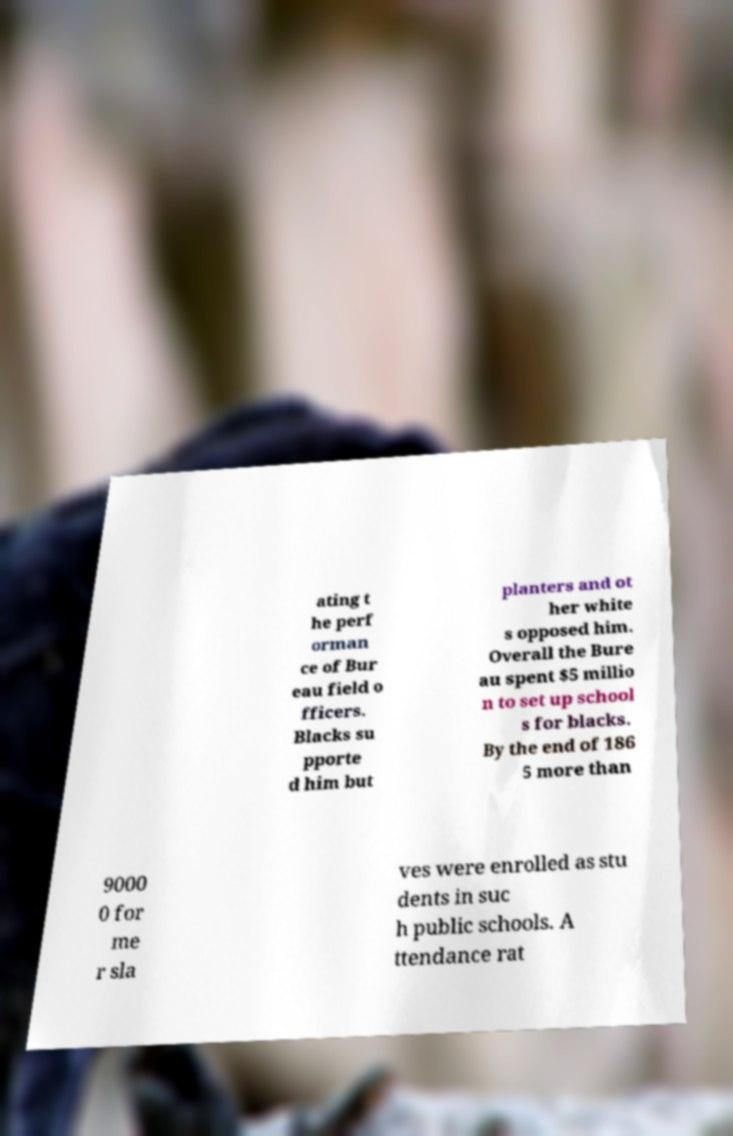Could you extract and type out the text from this image? ating t he perf orman ce of Bur eau field o fficers. Blacks su pporte d him but planters and ot her white s opposed him. Overall the Bure au spent $5 millio n to set up school s for blacks. By the end of 186 5 more than 9000 0 for me r sla ves were enrolled as stu dents in suc h public schools. A ttendance rat 